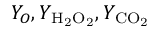Convert formula to latex. <formula><loc_0><loc_0><loc_500><loc_500>Y _ { O } , Y _ { { H _ { 2 } O _ { 2 } } } , Y _ { { C O _ { 2 } } }</formula> 